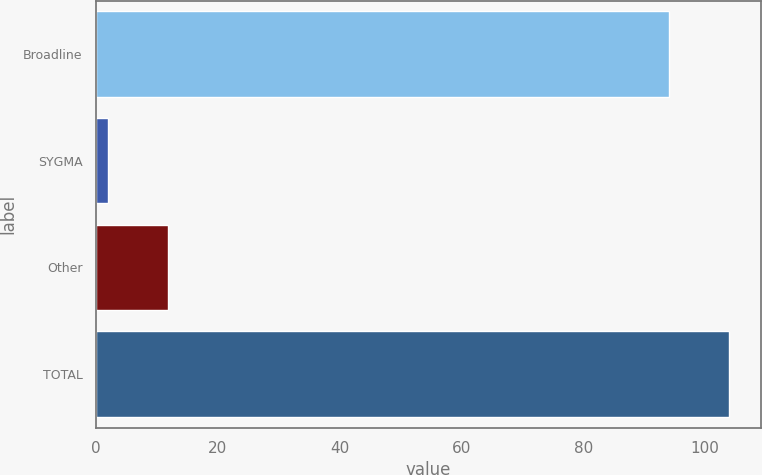Convert chart to OTSL. <chart><loc_0><loc_0><loc_500><loc_500><bar_chart><fcel>Broadline<fcel>SYGMA<fcel>Other<fcel>TOTAL<nl><fcel>94.1<fcel>2<fcel>11.8<fcel>103.9<nl></chart> 